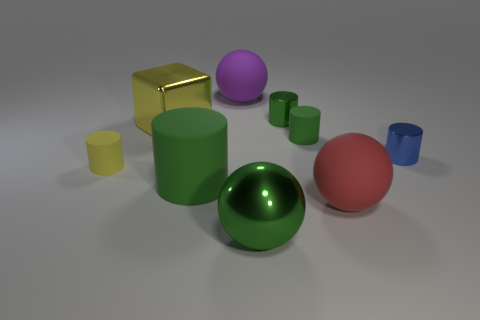Subtract all green cylinders. How many were subtracted if there are1green cylinders left? 2 Subtract all large cylinders. How many cylinders are left? 4 Subtract all blue cylinders. How many cylinders are left? 4 Subtract all cylinders. How many objects are left? 4 Subtract 5 cylinders. How many cylinders are left? 0 Subtract all tiny shiny cylinders. Subtract all big purple spheres. How many objects are left? 6 Add 2 large purple objects. How many large purple objects are left? 3 Add 7 big balls. How many big balls exist? 10 Subtract 1 yellow cubes. How many objects are left? 8 Subtract all yellow cylinders. Subtract all brown cubes. How many cylinders are left? 4 